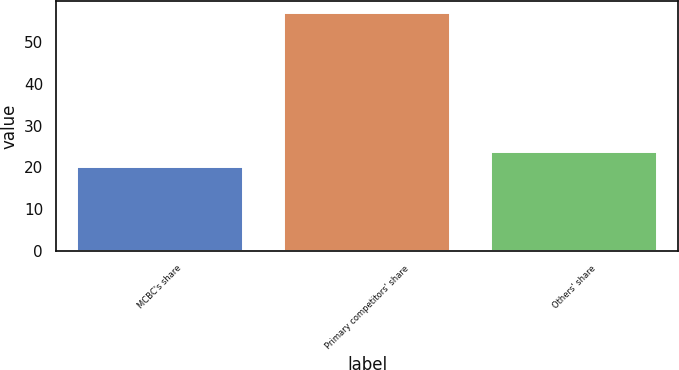<chart> <loc_0><loc_0><loc_500><loc_500><bar_chart><fcel>MCBC's share<fcel>Primary competitors' share<fcel>Others' share<nl><fcel>20<fcel>57<fcel>23.7<nl></chart> 